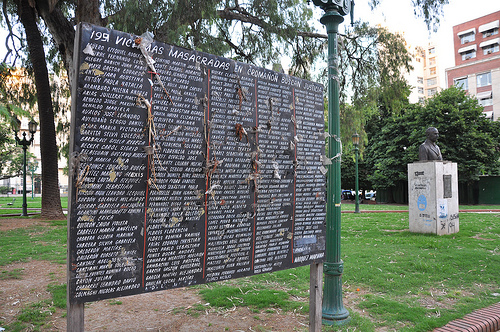<image>
Is the statue above the grass? Yes. The statue is positioned above the grass in the vertical space, higher up in the scene. 